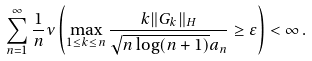Convert formula to latex. <formula><loc_0><loc_0><loc_500><loc_500>\sum _ { n = 1 } ^ { \infty } \frac { 1 } { n } { \mathbb { \nu } } \left ( \max _ { 1 \leq k \leq n } \frac { k \| G _ { k } \| _ { H } } { \sqrt { n \log ( n + 1 ) } a _ { n } } \geq \varepsilon \right ) < \infty \, .</formula> 